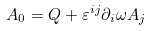<formula> <loc_0><loc_0><loc_500><loc_500>A _ { 0 } = Q + \varepsilon ^ { i j } \partial _ { i } \omega A _ { j }</formula> 